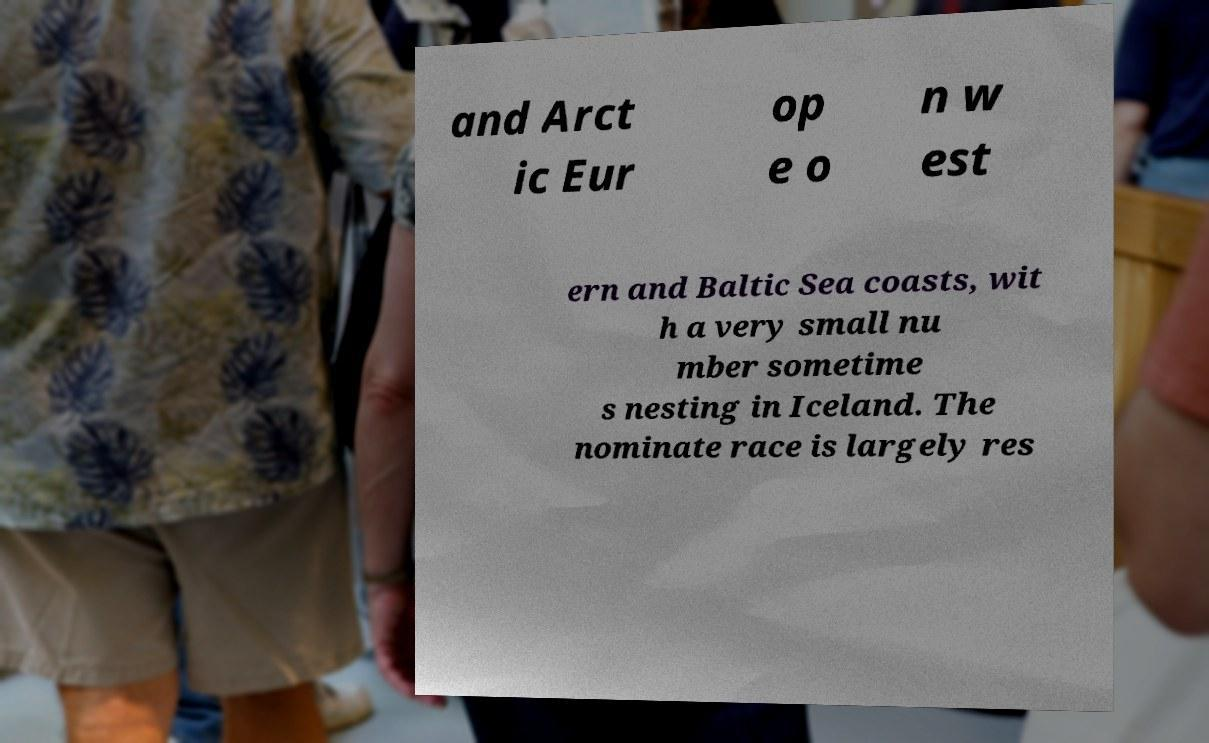There's text embedded in this image that I need extracted. Can you transcribe it verbatim? and Arct ic Eur op e o n w est ern and Baltic Sea coasts, wit h a very small nu mber sometime s nesting in Iceland. The nominate race is largely res 